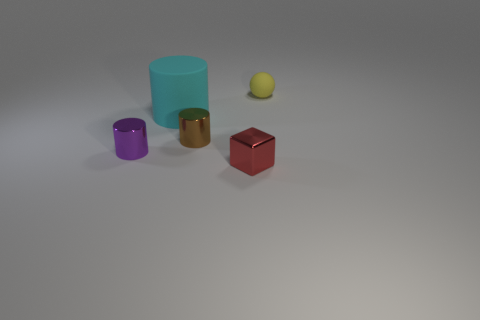Is the color of the small metallic block the same as the large cylinder? No, the small metallic block has a red hue, while the large cylinder displays a cyan tone. These colors are distinct, providing a clear contrast between the two objects. 